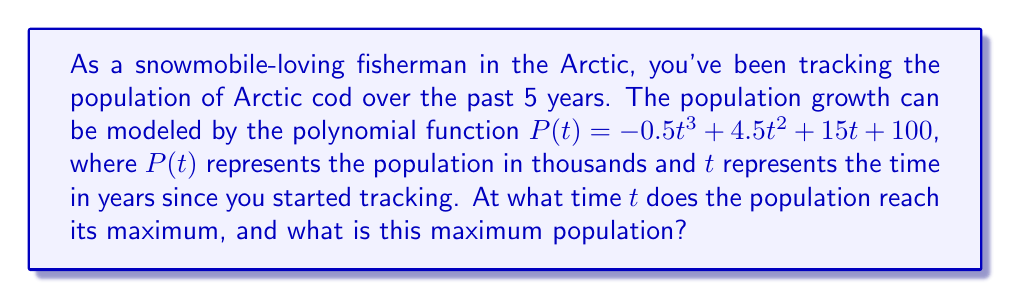Help me with this question. To find the maximum population, we need to follow these steps:

1) First, we need to find the derivative of the population function $P(t)$:

   $$P'(t) = -1.5t^2 + 9t + 15$$

2) The maximum population occurs when the rate of change is zero, so we set $P'(t) = 0$:

   $$-1.5t^2 + 9t + 15 = 0$$

3) This is a quadratic equation. We can solve it using the quadratic formula:

   $$t = \frac{-b \pm \sqrt{b^2 - 4ac}}{2a}$$

   where $a = -1.5$, $b = 9$, and $c = 15$

4) Plugging in these values:

   $$t = \frac{-9 \pm \sqrt{81 - 4(-1.5)(15)}}{2(-1.5)}$$
   $$= \frac{-9 \pm \sqrt{171}}{-3}$$

5) Solving this:

   $$t \approx 5.47 \text{ or } t \approx 0.53$$

6) Since we're looking for a maximum, we choose the larger value: $t \approx 5.47$ years.

7) To find the maximum population, we plug this value back into our original function:

   $$P(5.47) = -0.5(5.47)^3 + 4.5(5.47)^2 + 15(5.47) + 100$$
   $$\approx 240.8$$

Therefore, the population reaches its maximum of approximately 240,800 Arctic cod after about 5.47 years.
Answer: The population reaches its maximum after approximately 5.47 years, and the maximum population is approximately 240,800 Arctic cod. 